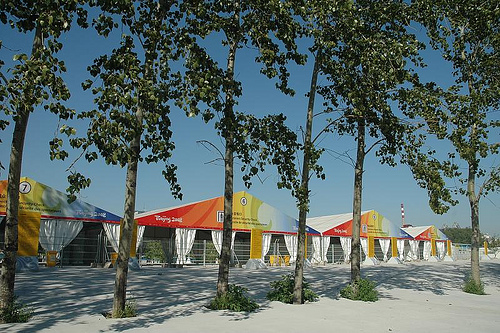<image>
Is the tree next to the stand? Yes. The tree is positioned adjacent to the stand, located nearby in the same general area. 